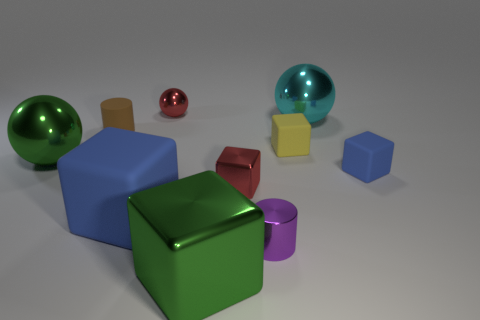Subtract all green blocks. How many blocks are left? 4 Subtract all large balls. How many balls are left? 1 Subtract all cyan blocks. Subtract all blue cylinders. How many blocks are left? 5 Subtract all spheres. How many objects are left? 7 Add 5 large cubes. How many large cubes exist? 7 Subtract 0 gray cylinders. How many objects are left? 10 Subtract all tiny yellow spheres. Subtract all tiny blue blocks. How many objects are left? 9 Add 1 matte things. How many matte things are left? 5 